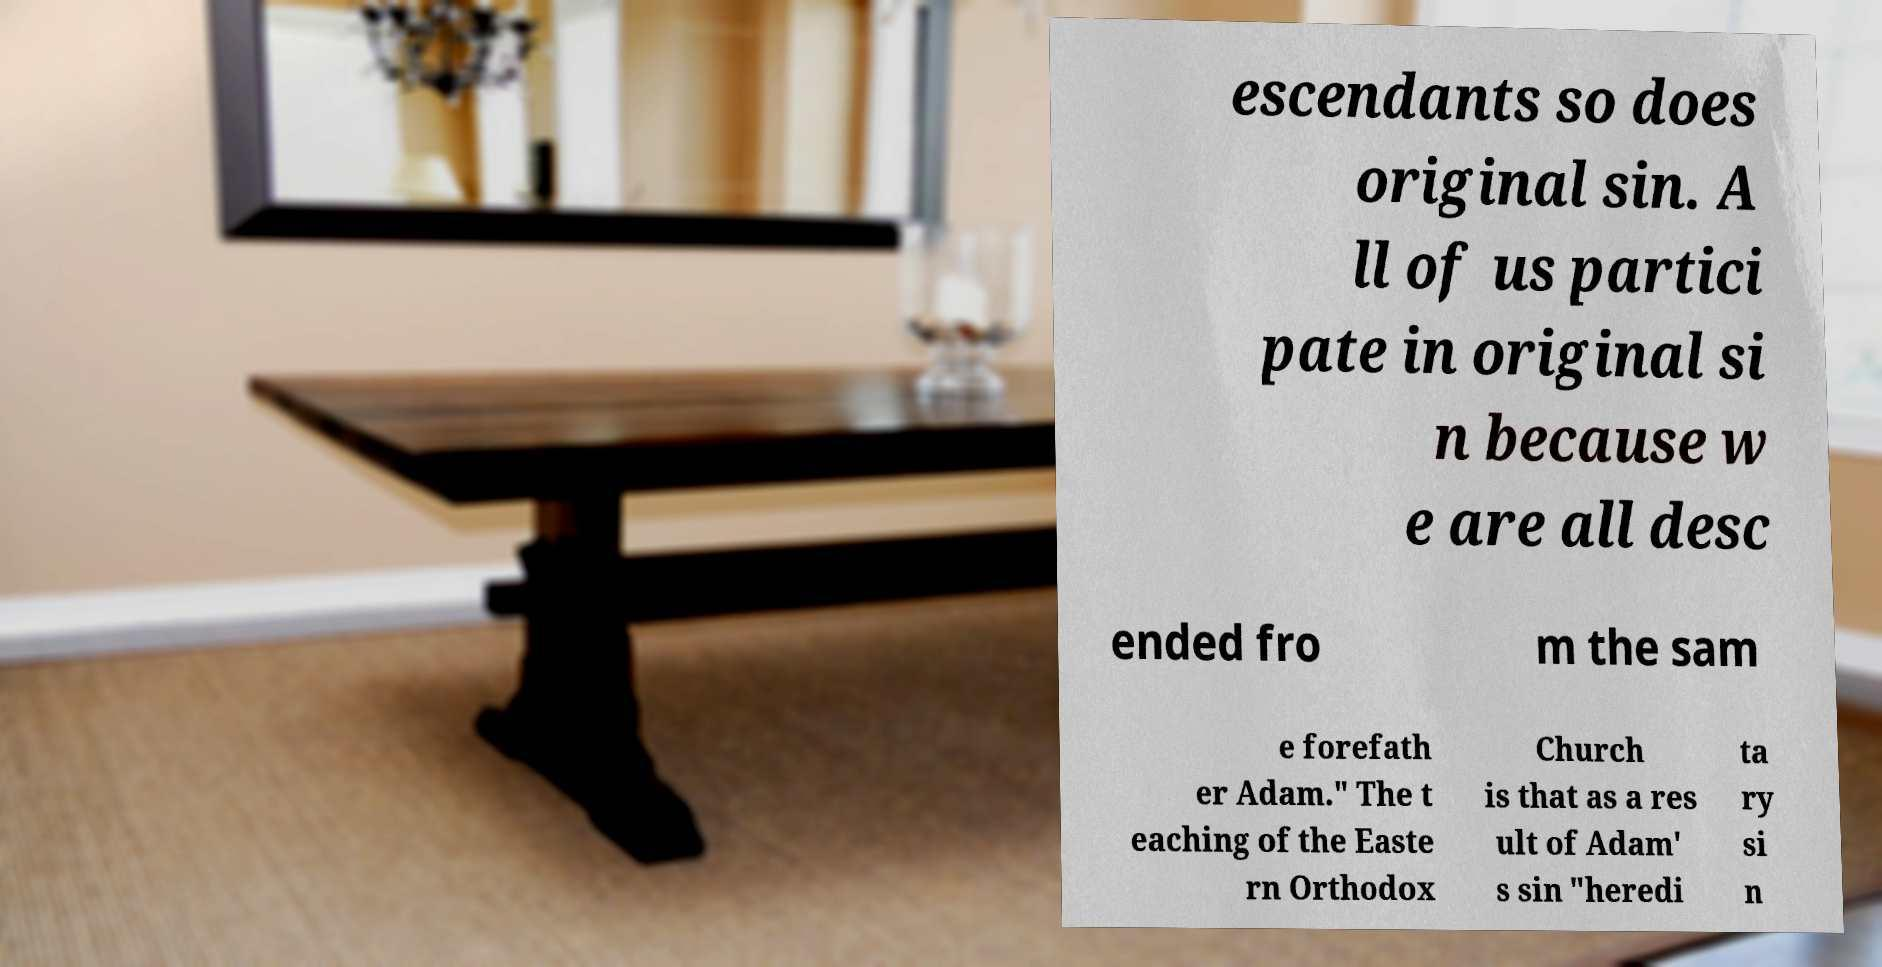Could you assist in decoding the text presented in this image and type it out clearly? escendants so does original sin. A ll of us partici pate in original si n because w e are all desc ended fro m the sam e forefath er Adam." The t eaching of the Easte rn Orthodox Church is that as a res ult of Adam' s sin "heredi ta ry si n 